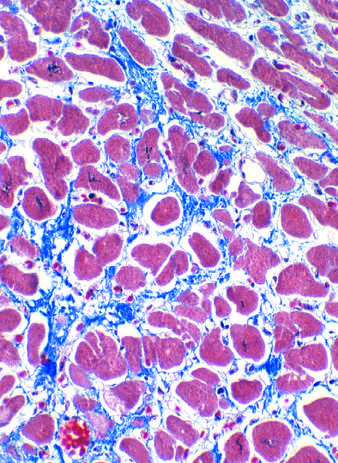s margin p blue in this masson trichrome-stained preparation?
Answer the question using a single word or phrase. No 